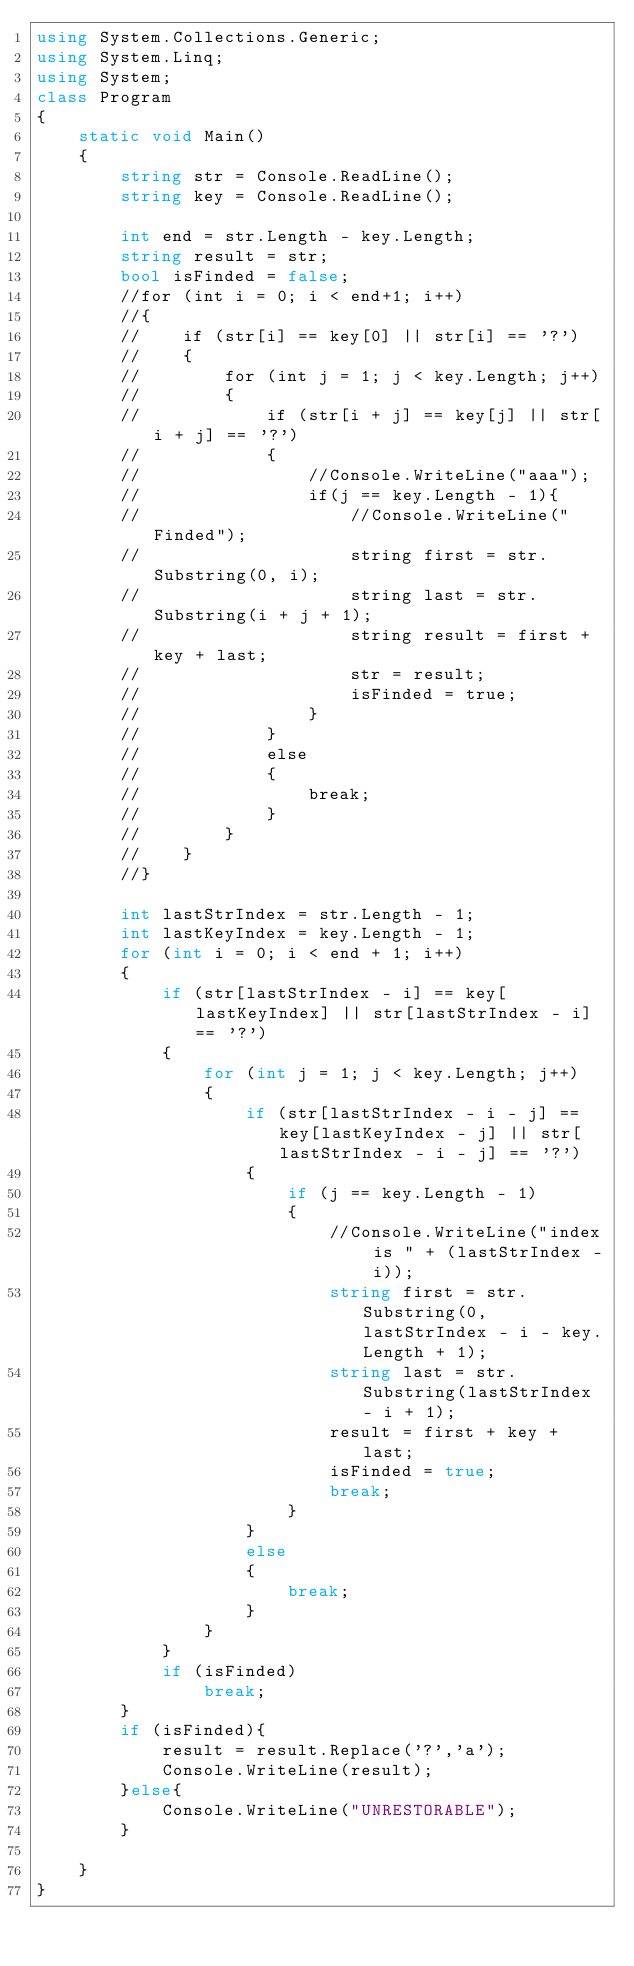<code> <loc_0><loc_0><loc_500><loc_500><_C#_>using System.Collections.Generic;
using System.Linq;
using System;
class Program
{
    static void Main()
    {
        string str = Console.ReadLine();
        string key = Console.ReadLine();

        int end = str.Length - key.Length;
        string result = str;
        bool isFinded = false;
        //for (int i = 0; i < end+1; i++)
        //{
        //    if (str[i] == key[0] || str[i] == '?')
        //    {
        //        for (int j = 1; j < key.Length; j++)
        //        {
        //            if (str[i + j] == key[j] || str[i + j] == '?')
        //            {
        //                //Console.WriteLine("aaa");
        //                if(j == key.Length - 1){
        //                    //Console.WriteLine("Finded");
        //                    string first = str.Substring(0, i);
        //                    string last = str.Substring(i + j + 1);
        //                    string result = first + key + last;
        //                    str = result;
        //                    isFinded = true;
        //                }
        //            }
        //            else
        //            {
        //                break;
        //            }
        //        }
        //    }
        //}

        int lastStrIndex = str.Length - 1;
        int lastKeyIndex = key.Length - 1;
        for (int i = 0; i < end + 1; i++)
        {
            if (str[lastStrIndex - i] == key[lastKeyIndex] || str[lastStrIndex - i] == '?')
            {
                for (int j = 1; j < key.Length; j++)
                {
                    if (str[lastStrIndex - i - j] == key[lastKeyIndex - j] || str[lastStrIndex - i - j] == '?')
                    {
                        if (j == key.Length - 1)
                        {
                            //Console.WriteLine("index is " + (lastStrIndex - i));
                            string first = str.Substring(0, lastStrIndex - i - key.Length + 1);
                            string last = str.Substring(lastStrIndex - i + 1);
                            result = first + key + last;
                            isFinded = true;
                            break;
                        }
                    }
                    else
                    {
                        break;
                    }
                }
            }
            if (isFinded)
                break;
        }
        if (isFinded){
            result = result.Replace('?','a');
            Console.WriteLine(result);
        }else{
            Console.WriteLine("UNRESTORABLE");
        }

    }
}</code> 